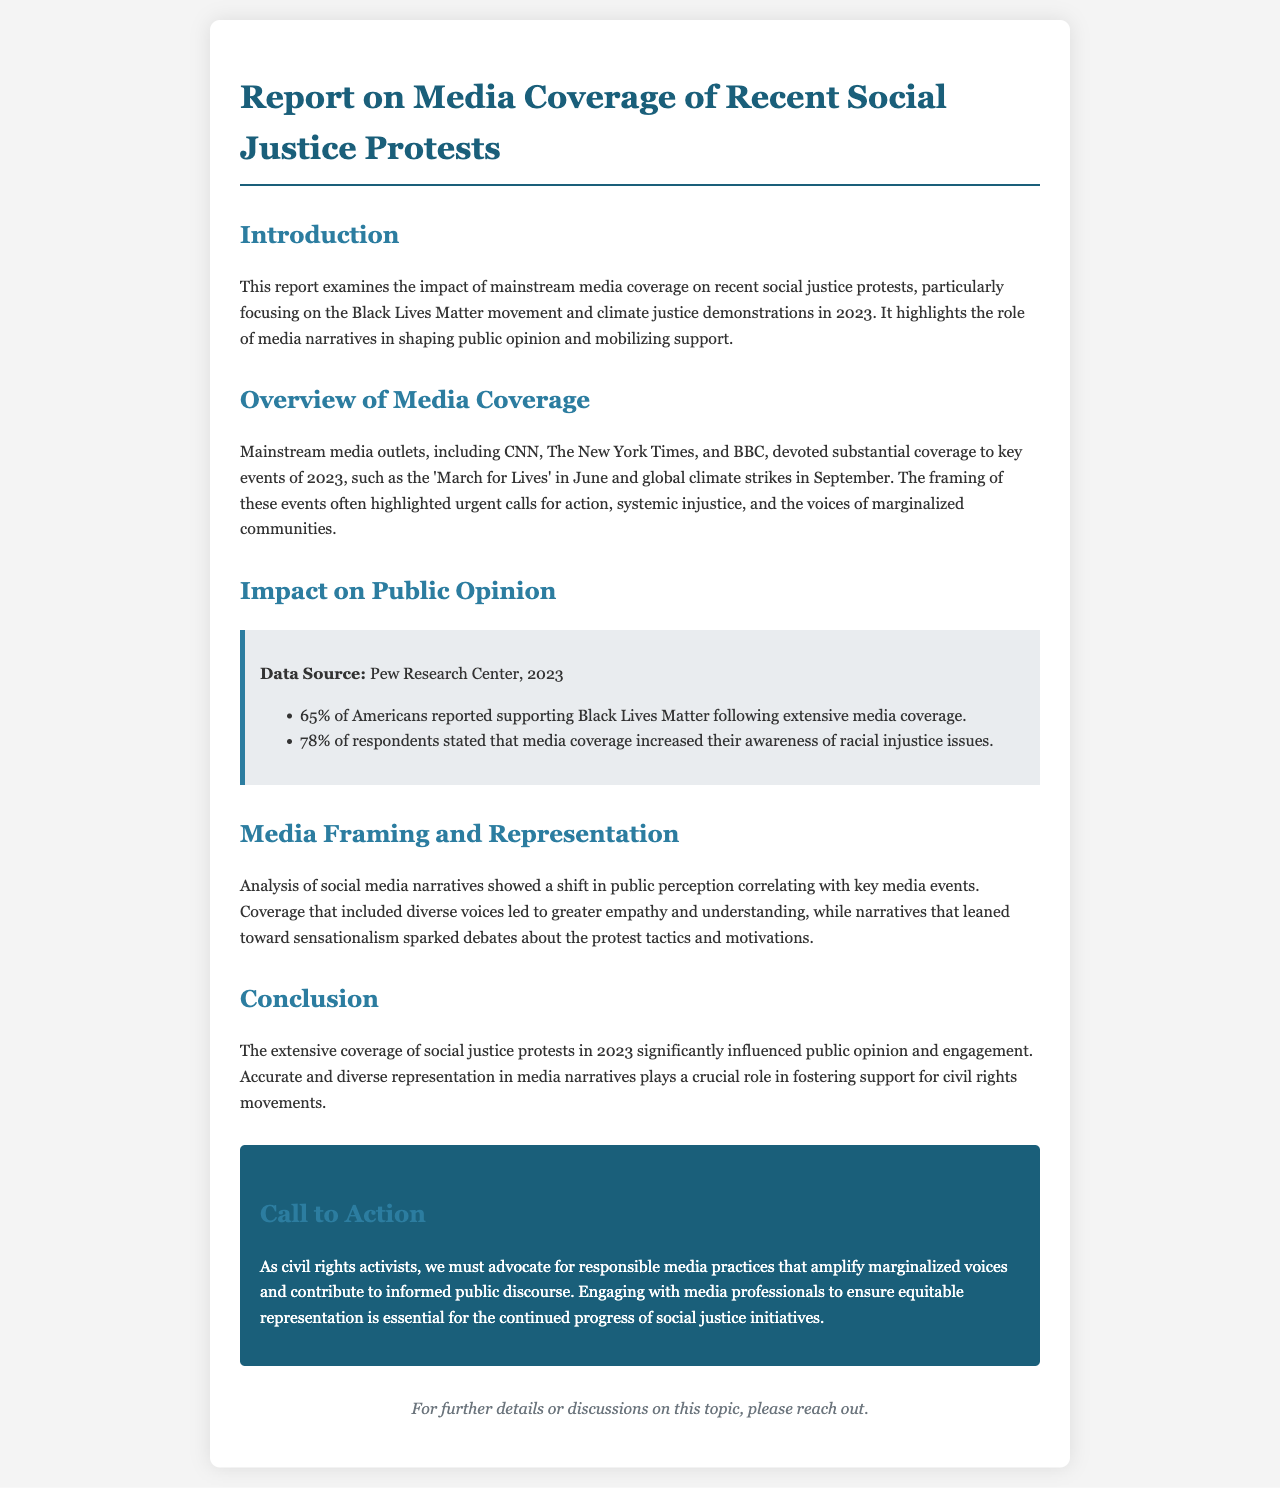What is the main topic of the report? The report examines the impact of mainstream media coverage on recent social justice protests.
Answer: Media coverage of social justice protests What percentage of Americans supported Black Lives Matter after media coverage? The document states that 65% of Americans reported supporting Black Lives Matter following extensive media coverage.
Answer: 65% Which event occurred in June 2023? The report mentions the 'March for Lives' as a key event that took place in June.
Answer: March for Lives What role do diverse voices play in media coverage? The document highlights that including diverse voices in coverage leads to greater empathy and understanding.
Answer: Greater empathy and understanding What does the report suggest as a call to action? The report calls for civil rights activists to advocate for responsible media practices that amplify marginalized voices.
Answer: Advocate for responsible media practices What percentage of respondents increased their awareness of racial injustice issues due to media? According to the document, 78% of respondents stated that media coverage increased their awareness of racial injustice issues.
Answer: 78% What month had global climate strikes in 2023? The document indicates that global climate strikes took place in September.
Answer: September What type of media outlets were highlighted in the report? The report mentions mainstream media outlets such as CNN, The New York Times, and BBC.
Answer: CNN, The New York Times, BBC 